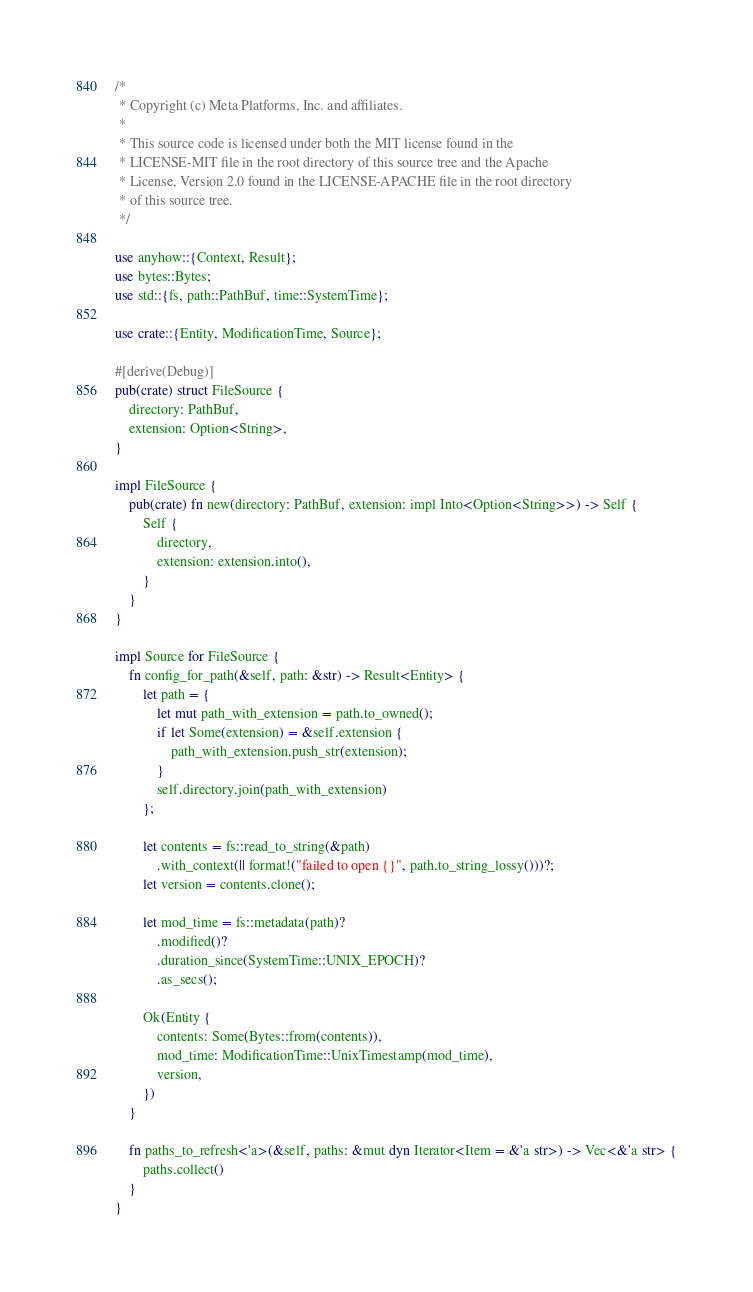<code> <loc_0><loc_0><loc_500><loc_500><_Rust_>/*
 * Copyright (c) Meta Platforms, Inc. and affiliates.
 *
 * This source code is licensed under both the MIT license found in the
 * LICENSE-MIT file in the root directory of this source tree and the Apache
 * License, Version 2.0 found in the LICENSE-APACHE file in the root directory
 * of this source tree.
 */

use anyhow::{Context, Result};
use bytes::Bytes;
use std::{fs, path::PathBuf, time::SystemTime};

use crate::{Entity, ModificationTime, Source};

#[derive(Debug)]
pub(crate) struct FileSource {
    directory: PathBuf,
    extension: Option<String>,
}

impl FileSource {
    pub(crate) fn new(directory: PathBuf, extension: impl Into<Option<String>>) -> Self {
        Self {
            directory,
            extension: extension.into(),
        }
    }
}

impl Source for FileSource {
    fn config_for_path(&self, path: &str) -> Result<Entity> {
        let path = {
            let mut path_with_extension = path.to_owned();
            if let Some(extension) = &self.extension {
                path_with_extension.push_str(extension);
            }
            self.directory.join(path_with_extension)
        };

        let contents = fs::read_to_string(&path)
            .with_context(|| format!("failed to open {}", path.to_string_lossy()))?;
        let version = contents.clone();

        let mod_time = fs::metadata(path)?
            .modified()?
            .duration_since(SystemTime::UNIX_EPOCH)?
            .as_secs();

        Ok(Entity {
            contents: Some(Bytes::from(contents)),
            mod_time: ModificationTime::UnixTimestamp(mod_time),
            version,
        })
    }

    fn paths_to_refresh<'a>(&self, paths: &mut dyn Iterator<Item = &'a str>) -> Vec<&'a str> {
        paths.collect()
    }
}
</code> 